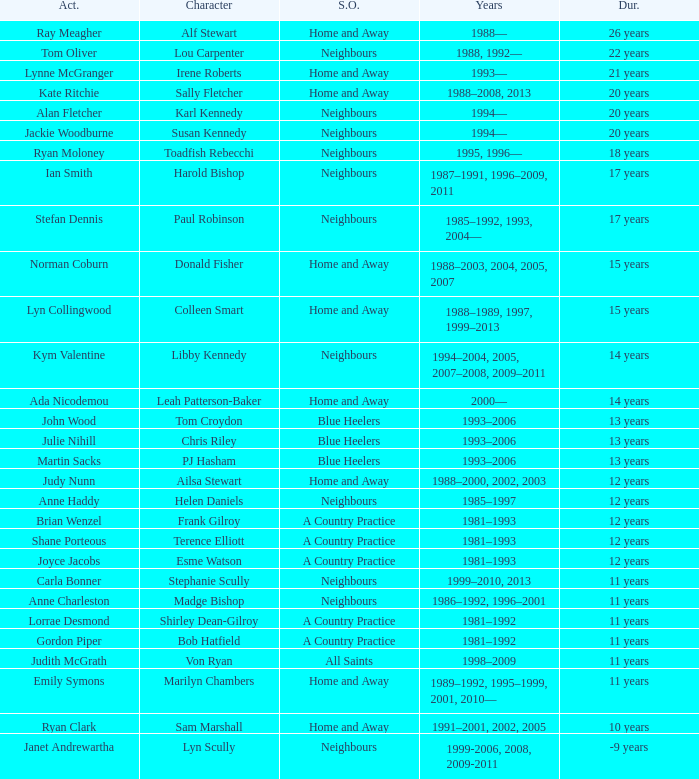What character was portrayed by the same actor for 12 years on Neighbours? Helen Daniels. 